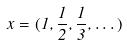Convert formula to latex. <formula><loc_0><loc_0><loc_500><loc_500>x = ( 1 , \frac { 1 } { 2 } , \frac { 1 } { 3 } , \dots )</formula> 